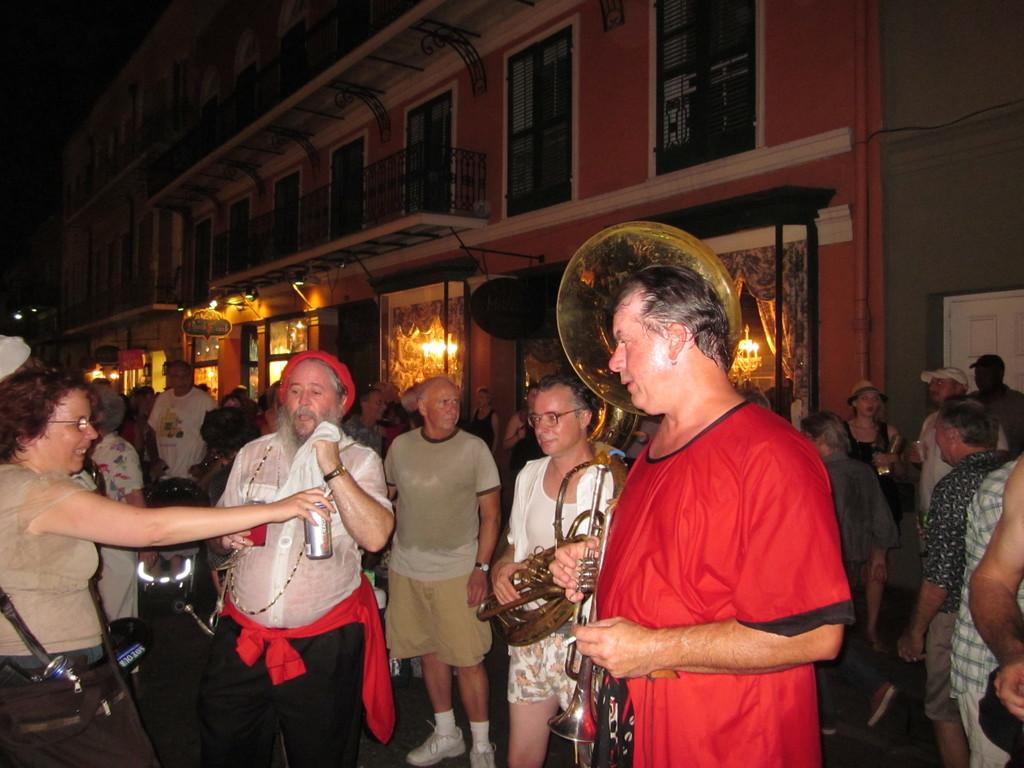What is the gender of the person on the left side of the image? There is a woman standing on the left side of the image. What is the gender of the person on the right side of the image? There is a man standing on the right side of the image. What color is the t-shirt worn by the man in the image? The man is wearing a red color t-shirt. How many people are visible in the image? There are other people standing in the image, in addition to the woman and the man. What is the main structure in the middle of the image? There is a building in the middle of the image. What type of skirt is the woman wearing in the image? There is no skirt visible in the image; the woman is wearing a t-shirt and pants. What book is the woman reading in the image? There is no book or reading activity depicted in the image. 